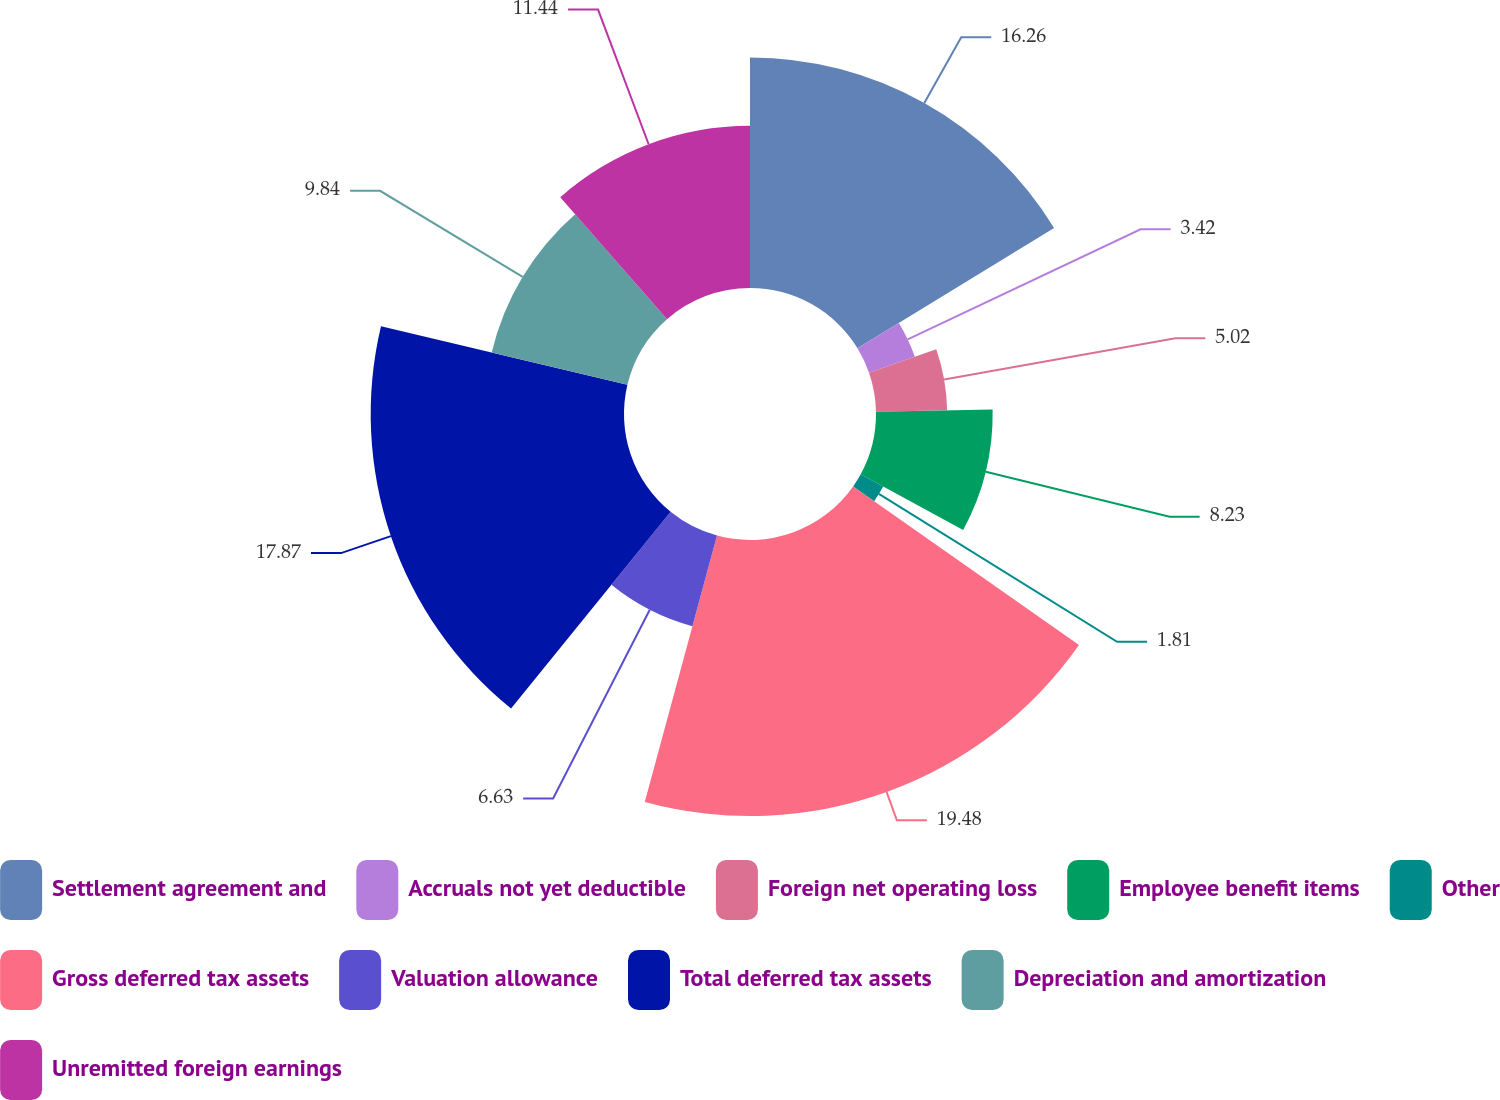<chart> <loc_0><loc_0><loc_500><loc_500><pie_chart><fcel>Settlement agreement and<fcel>Accruals not yet deductible<fcel>Foreign net operating loss<fcel>Employee benefit items<fcel>Other<fcel>Gross deferred tax assets<fcel>Valuation allowance<fcel>Total deferred tax assets<fcel>Depreciation and amortization<fcel>Unremitted foreign earnings<nl><fcel>16.26%<fcel>3.42%<fcel>5.02%<fcel>8.23%<fcel>1.81%<fcel>19.47%<fcel>6.63%<fcel>17.87%<fcel>9.84%<fcel>11.44%<nl></chart> 